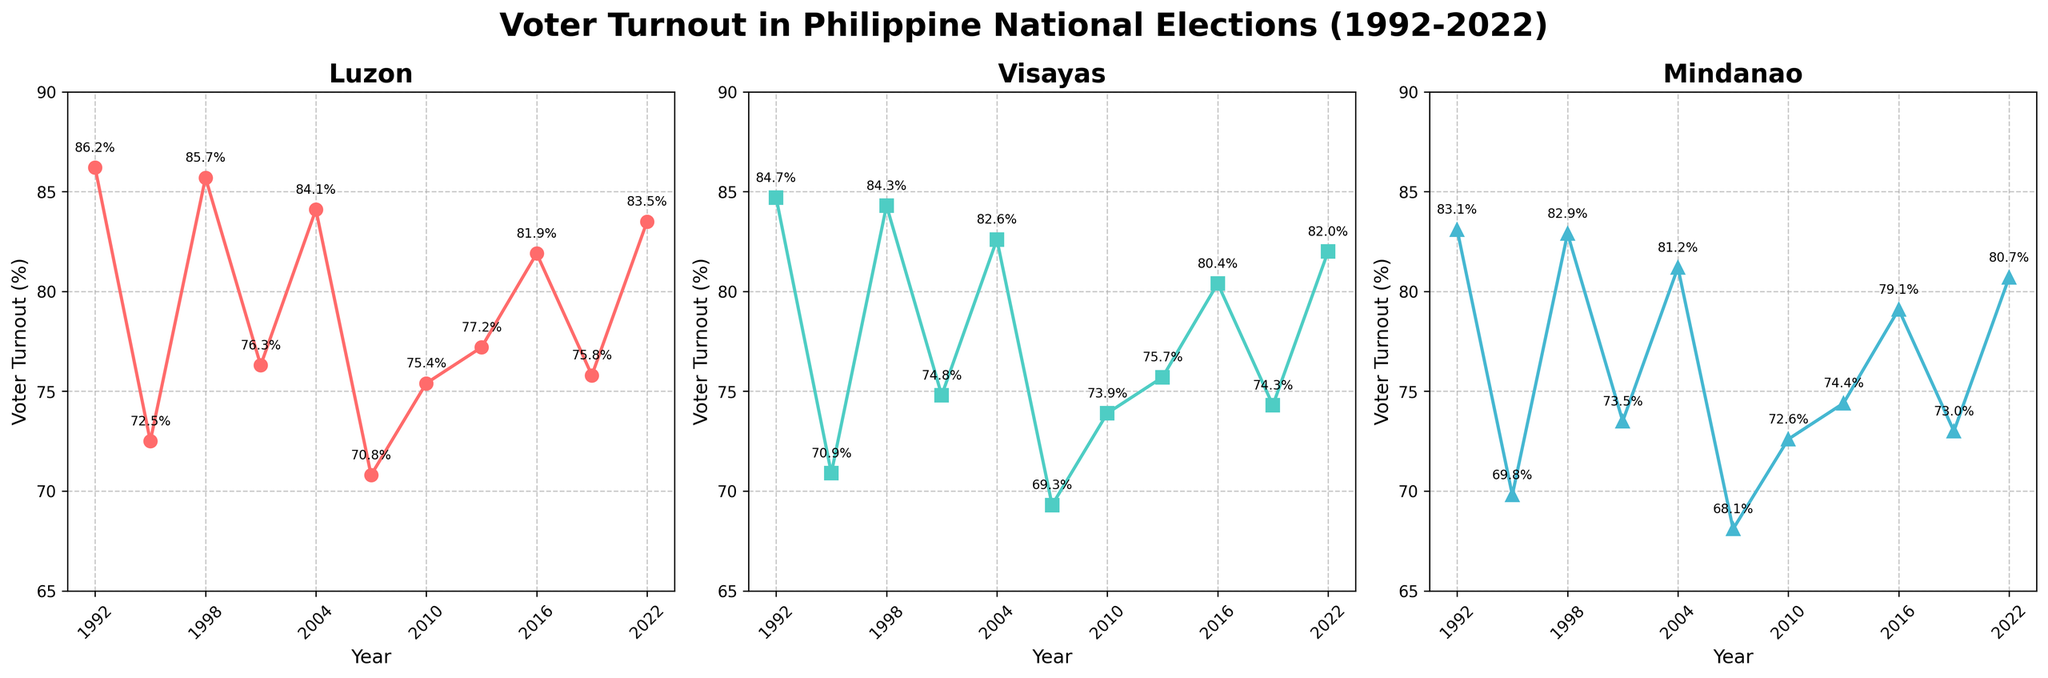What's the trend of voter turnout in Luzon over the years? The voter turnout in Luzon generally fluctuates over the years. There are peaks in 1992, 1998, 2004, 2016, and 2022, with significant dips in 1995 and 2007.
Answer: Fluctuating with peaks in 1992, 1998, 2004, 2016, 2022, and dips in 1995, 2007 Which region had the highest voter turnout in the latest election? Observing the data points for the year 2022, Luzon has the highest voter turnout at 83.5%, compared to Visayas at 82.0% and Mindanao at 80.7%.
Answer: Luzon Between which consecutive years did Visayas experience its largest decrease in voter turnout? Comparing the values year by year for Visayas, the largest decrease occurs between 1992 (84.7%) and 1995 (70.9%), which is a drop of 13.8%.
Answer: Between 1992 and 1995 In which year did all three regions have both their peaks and lows in voter turnout? 1995 and 2007 represent years where all three regions experienced lows in voter turnout: 69.8% in Mindanao, 70.9% in Visayas, and 72.5% in Luzon. Similarly, there are individual peaks in 1992, 1998, 2004, 2016, and 2022.
Answer: 1995 and 2007 for lows What is the average voter turnout of Mindanao from 1992 to 2022? To find the average, sum the voter turnout percentages for Mindanao from all the years: (83.1 + 69.8 + 82.9 + 73.5 + 81.2 + 68.1 + 72.6 + 74.4 + 79.1 + 73.0 + 80.7) and then divide by the number of entries, which is 11. The sum is 838.4, and the average is 838.4 / 11 ≈ 76.2%.
Answer: 76.2% How many times did Luzon have a voter turnout above 80%? Observing Luzon’s voter turnout, the years with values above 80% are 1992, 1998, 2004, 2016, and 2022. Counting these instances gives 5 times.
Answer: 5 times Which region shows the most consistent voter turnout over the period? By visually inspecting the lines, Visayas appears to have the least fluctuations compared to Luzon and Mindanao, indicating more consistent voter turnout.
Answer: Visayas In which election year did the gap between Luzon and Mindanao voter turnout become the largest? Comparing the data points year by year, the largest gap between Luzon and Mindanao occurs in 1995 with a difference of 2.7% (Luzon at 72.5% and Mindanao at 69.8%).
Answer: 1995 Do Luzon and Visayas show similar trends in voter turnout changes? By observing their graphical lines, both regions exhibit similar trends with concurrent peaks and troughs, particularly in 1992, 1998, 2004, 2016, and slight divergences in 1995, 2007, indicating a general similarity.
Answer: Yes, they show similar trends Which year did voter turnout start to show an upward trend again after the lowest dip for Mindanao? For Mindanao, the lowest dip is in 2007 with a turnout of 68.1%. The upward trend starts from 2010 with a turnout of 72.6%.
Answer: 2010 